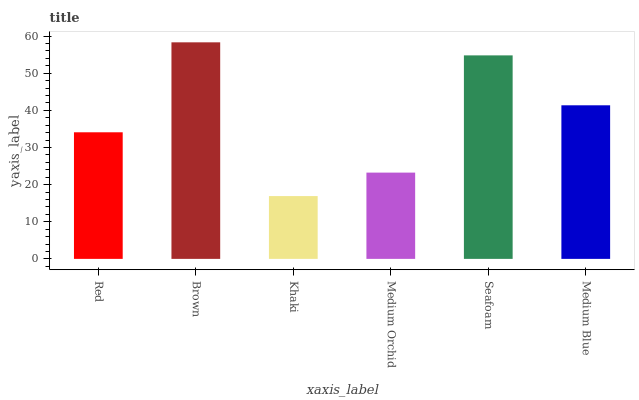Is Khaki the minimum?
Answer yes or no. Yes. Is Brown the maximum?
Answer yes or no. Yes. Is Brown the minimum?
Answer yes or no. No. Is Khaki the maximum?
Answer yes or no. No. Is Brown greater than Khaki?
Answer yes or no. Yes. Is Khaki less than Brown?
Answer yes or no. Yes. Is Khaki greater than Brown?
Answer yes or no. No. Is Brown less than Khaki?
Answer yes or no. No. Is Medium Blue the high median?
Answer yes or no. Yes. Is Red the low median?
Answer yes or no. Yes. Is Brown the high median?
Answer yes or no. No. Is Medium Orchid the low median?
Answer yes or no. No. 